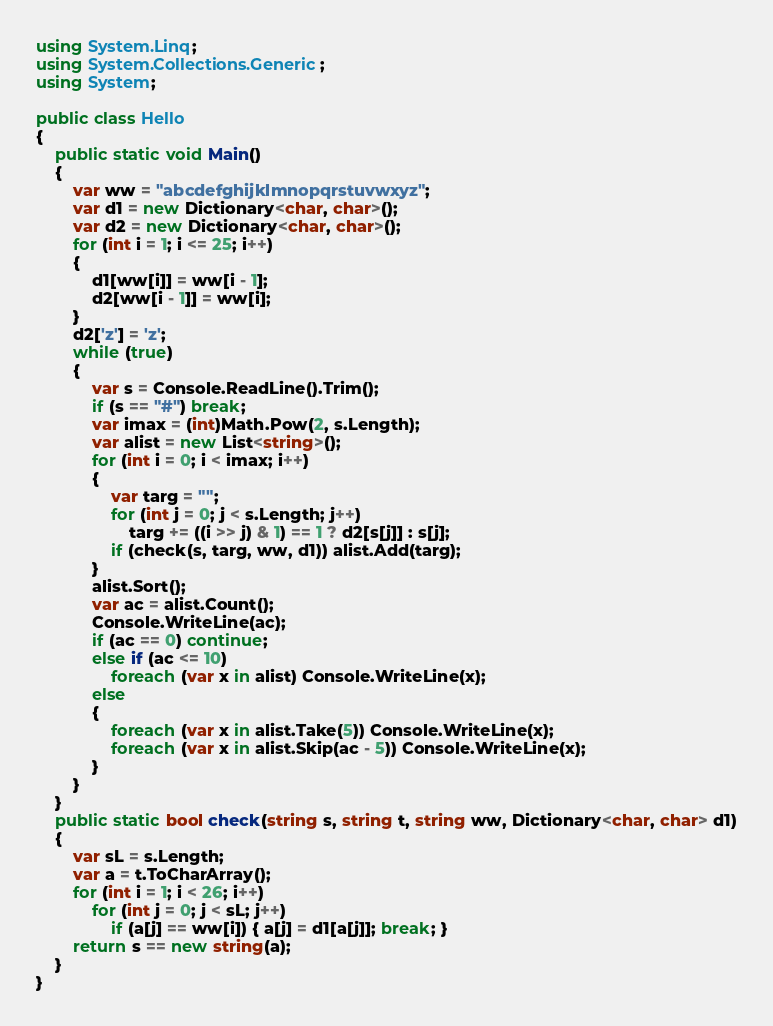Convert code to text. <code><loc_0><loc_0><loc_500><loc_500><_C#_>using System.Linq;
using System.Collections.Generic;
using System;

public class Hello
{
    public static void Main()
    {
        var ww = "abcdefghijklmnopqrstuvwxyz";
        var d1 = new Dictionary<char, char>();
        var d2 = new Dictionary<char, char>();
        for (int i = 1; i <= 25; i++)
        {
            d1[ww[i]] = ww[i - 1];
            d2[ww[i - 1]] = ww[i];
        }
        d2['z'] = 'z';
        while (true)
        {
            var s = Console.ReadLine().Trim();
            if (s == "#") break;
            var imax = (int)Math.Pow(2, s.Length);
            var alist = new List<string>();
            for (int i = 0; i < imax; i++)
            {
                var targ = "";
                for (int j = 0; j < s.Length; j++)
                    targ += ((i >> j) & 1) == 1 ? d2[s[j]] : s[j];
                if (check(s, targ, ww, d1)) alist.Add(targ);
            }
            alist.Sort();
            var ac = alist.Count();
            Console.WriteLine(ac);
            if (ac == 0) continue;
            else if (ac <= 10)
                foreach (var x in alist) Console.WriteLine(x);
            else
            {
                foreach (var x in alist.Take(5)) Console.WriteLine(x);
                foreach (var x in alist.Skip(ac - 5)) Console.WriteLine(x);
            }
        }
    }
    public static bool check(string s, string t, string ww, Dictionary<char, char> d1)
    {
        var sL = s.Length;
        var a = t.ToCharArray();
        for (int i = 1; i < 26; i++)
            for (int j = 0; j < sL; j++)
                if (a[j] == ww[i]) { a[j] = d1[a[j]]; break; }
        return s == new string(a);
    }
}

</code> 